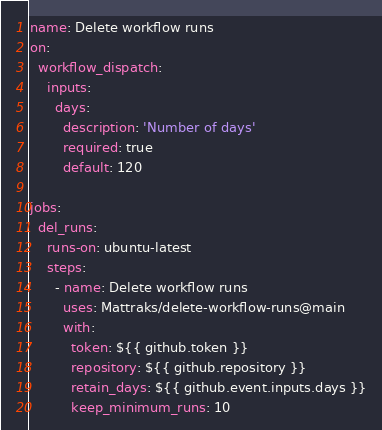Convert code to text. <code><loc_0><loc_0><loc_500><loc_500><_YAML_>name: Delete workflow runs
on:
  workflow_dispatch:
    inputs:
      days:
        description: 'Number of days'
        required: true
        default: 120

jobs:
  del_runs:
    runs-on: ubuntu-latest
    steps:
      - name: Delete workflow runs
        uses: Mattraks/delete-workflow-runs@main
        with:
          token: ${{ github.token }}
          repository: ${{ github.repository }}
          retain_days: ${{ github.event.inputs.days }}
          keep_minimum_runs: 10
</code> 